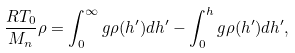Convert formula to latex. <formula><loc_0><loc_0><loc_500><loc_500>\frac { R T _ { 0 } } { M _ { n } } \rho = \int _ { 0 } ^ { \infty } g \rho ( h ^ { \prime } ) d h ^ { \prime } - \int _ { 0 } ^ { h } g \rho ( h ^ { \prime } ) d h ^ { \prime } ,</formula> 